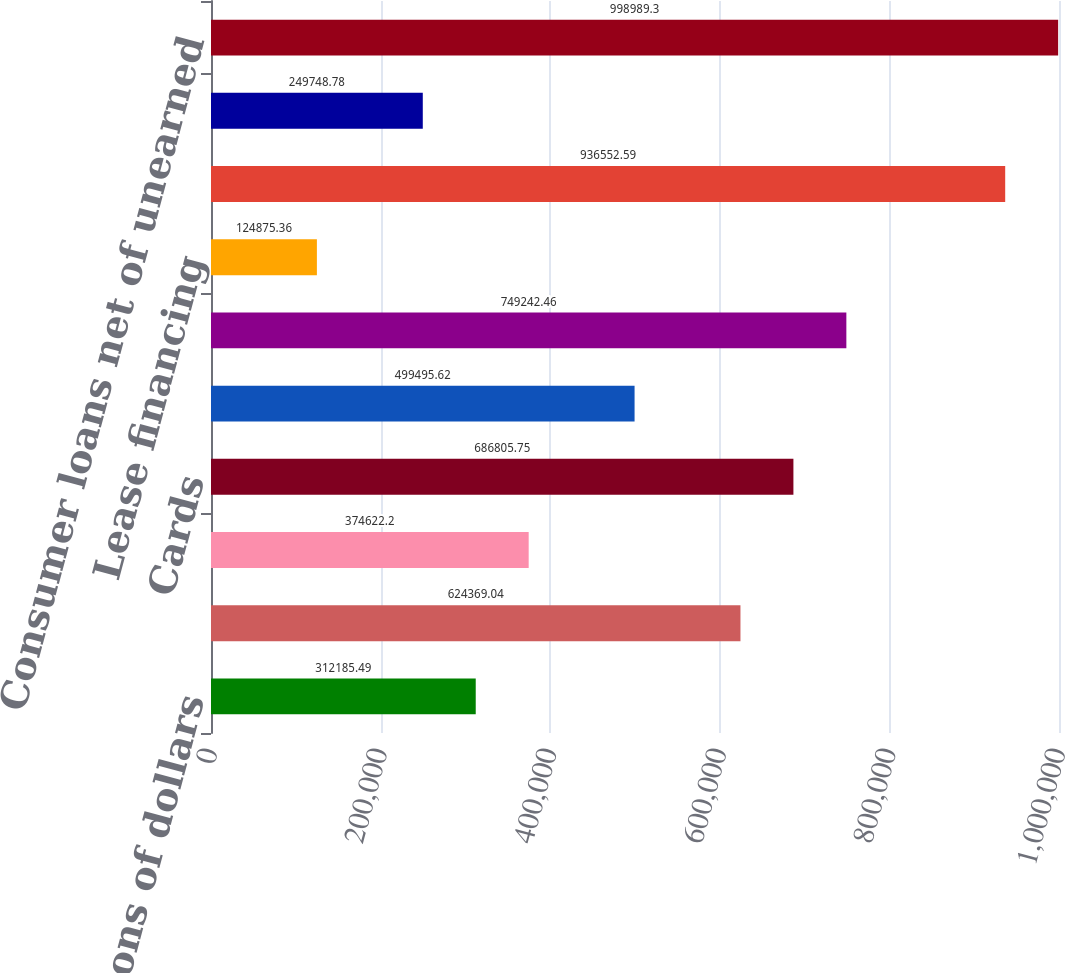Convert chart to OTSL. <chart><loc_0><loc_0><loc_500><loc_500><bar_chart><fcel>In millions of dollars<fcel>Mortgage and real estate (1)<fcel>Installment revolving credit<fcel>Cards<fcel>Commercial and industrial<fcel>Total<fcel>Lease financing<fcel>Total consumer loans<fcel>Unearned income (2)<fcel>Consumer loans net of unearned<nl><fcel>312185<fcel>624369<fcel>374622<fcel>686806<fcel>499496<fcel>749242<fcel>124875<fcel>936553<fcel>249749<fcel>998989<nl></chart> 